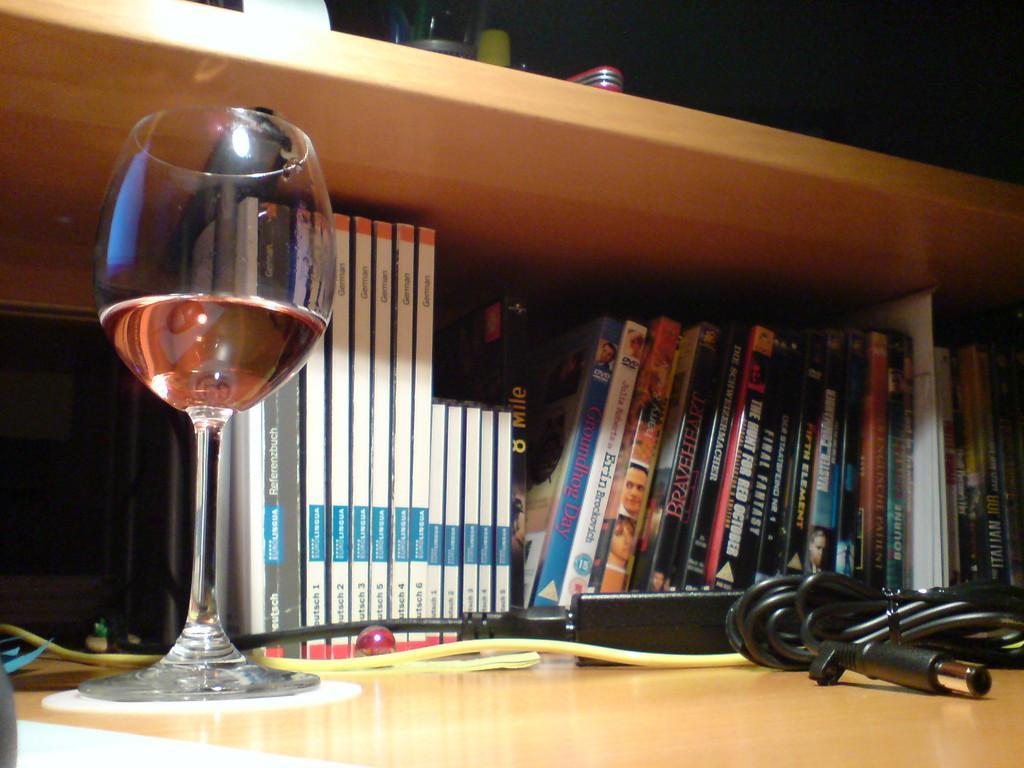Can you describe this image briefly? In this picture we can see books arranged in a sequence manner in a rack. Here we can see adapter and also a wine glass with wine. At the top we can see glass. 